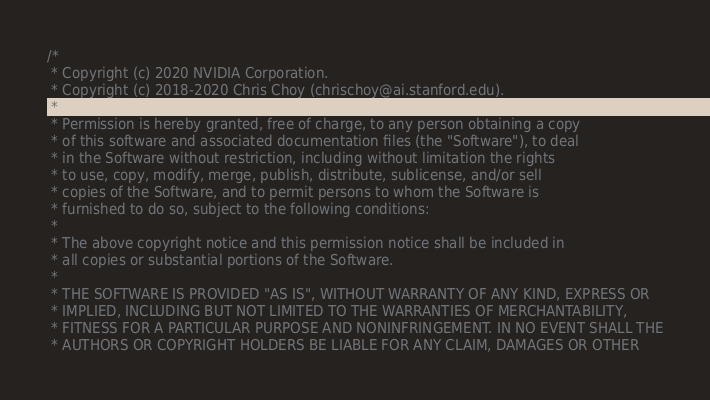Convert code to text. <code><loc_0><loc_0><loc_500><loc_500><_Cuda_>/*
 * Copyright (c) 2020 NVIDIA Corporation.
 * Copyright (c) 2018-2020 Chris Choy (chrischoy@ai.stanford.edu).
 *
 * Permission is hereby granted, free of charge, to any person obtaining a copy
 * of this software and associated documentation files (the "Software"), to deal
 * in the Software without restriction, including without limitation the rights
 * to use, copy, modify, merge, publish, distribute, sublicense, and/or sell
 * copies of the Software, and to permit persons to whom the Software is
 * furnished to do so, subject to the following conditions:
 *
 * The above copyright notice and this permission notice shall be included in
 * all copies or substantial portions of the Software.
 *
 * THE SOFTWARE IS PROVIDED "AS IS", WITHOUT WARRANTY OF ANY KIND, EXPRESS OR
 * IMPLIED, INCLUDING BUT NOT LIMITED TO THE WARRANTIES OF MERCHANTABILITY,
 * FITNESS FOR A PARTICULAR PURPOSE AND NONINFRINGEMENT. IN NO EVENT SHALL THE
 * AUTHORS OR COPYRIGHT HOLDERS BE LIABLE FOR ANY CLAIM, DAMAGES OR OTHER</code> 